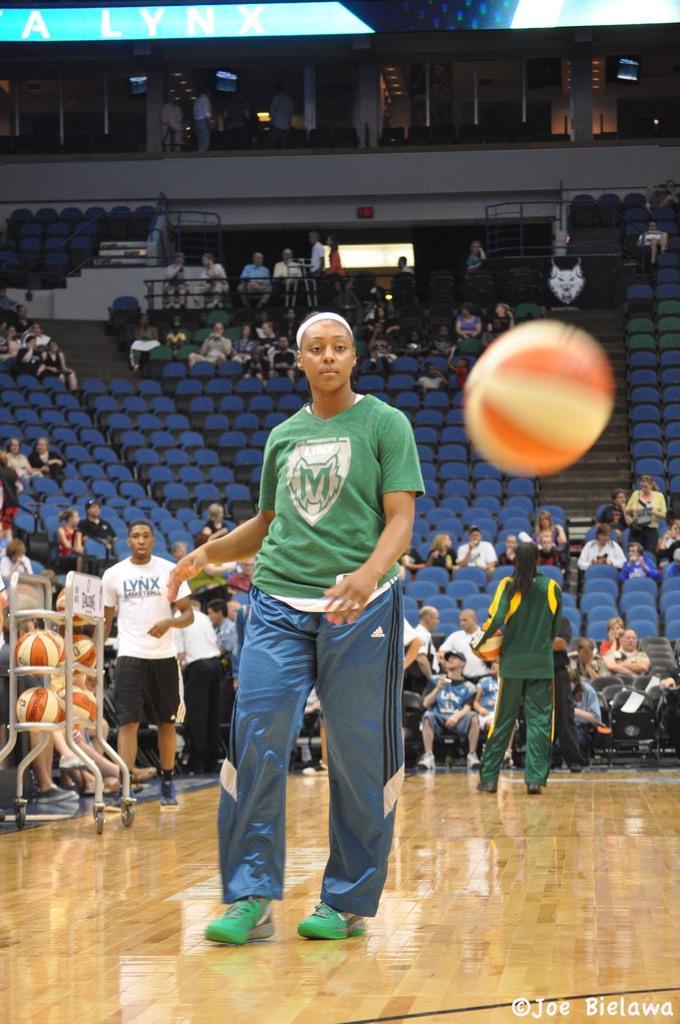How would you summarize this image in a sentence or two? In this picture we can see a ball is in the air, some people are on the ground, some people are sitting on chairs and in the background we can see rods, walls, some objects. 